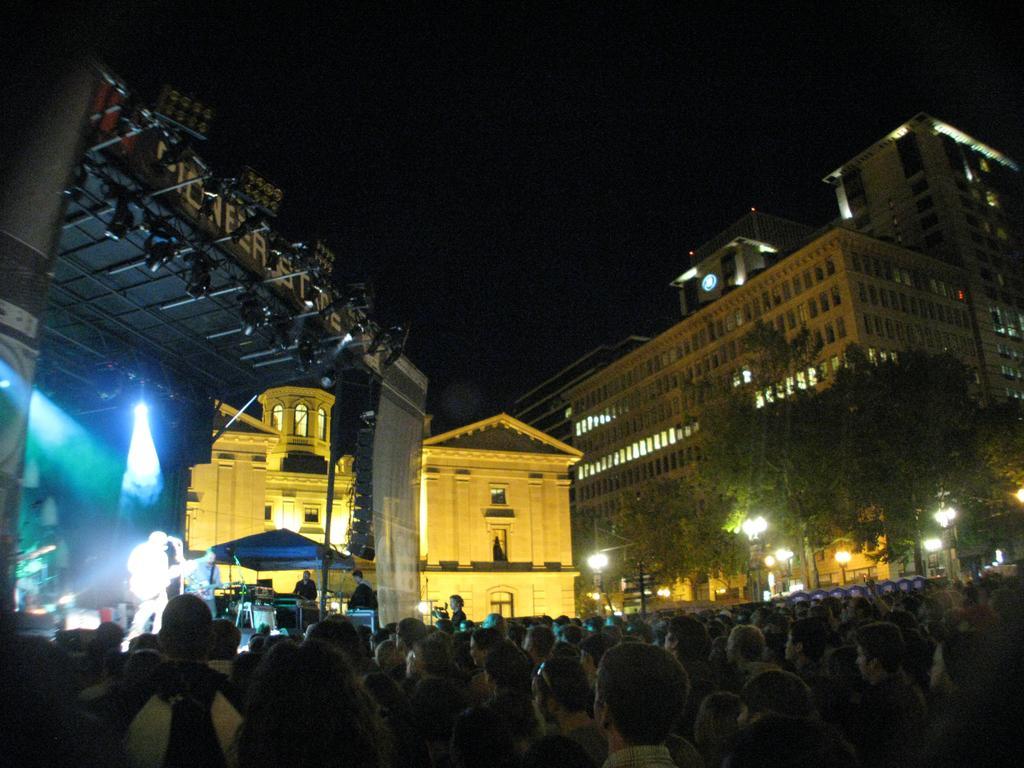Could you give a brief overview of what you see in this image? In this picture there are people, among them there are two people on the stage and playing musical instruments and we can see microphones with stands, tent, focusing lights, rods and few objects. In the background of the image we can see buildings, lights, trees and sky. 